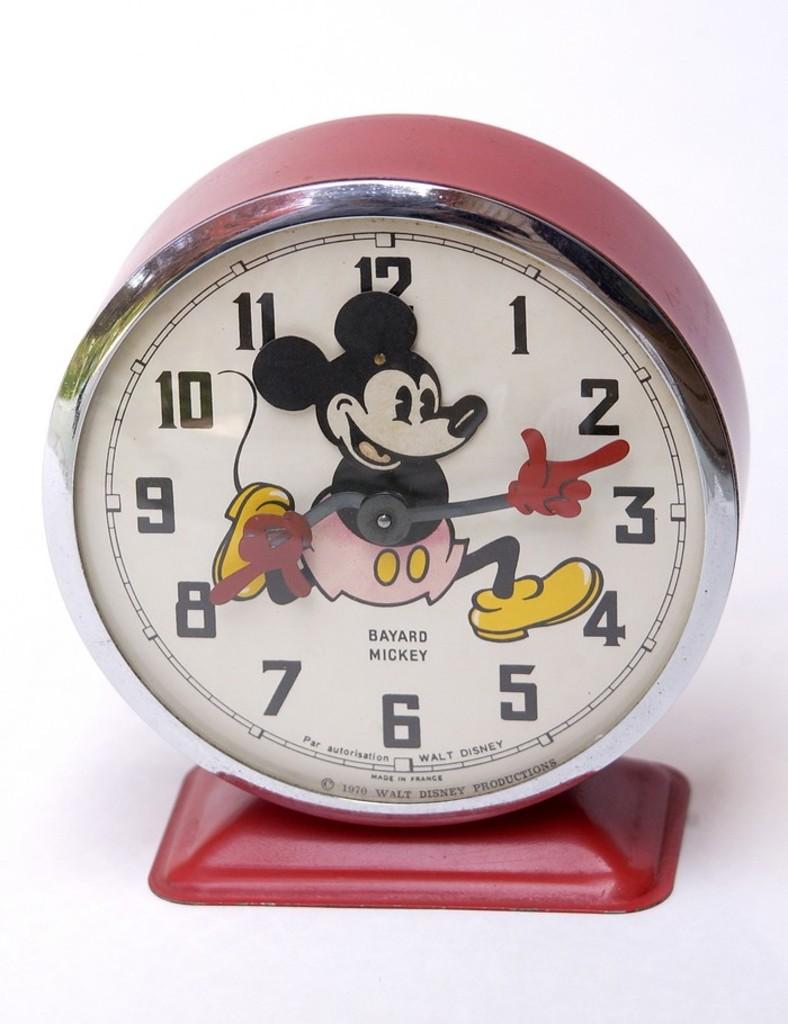What character is shown on this clock?
Offer a very short reply. Mickey. What is printed above the mickey typeface?
Provide a short and direct response. 12. 